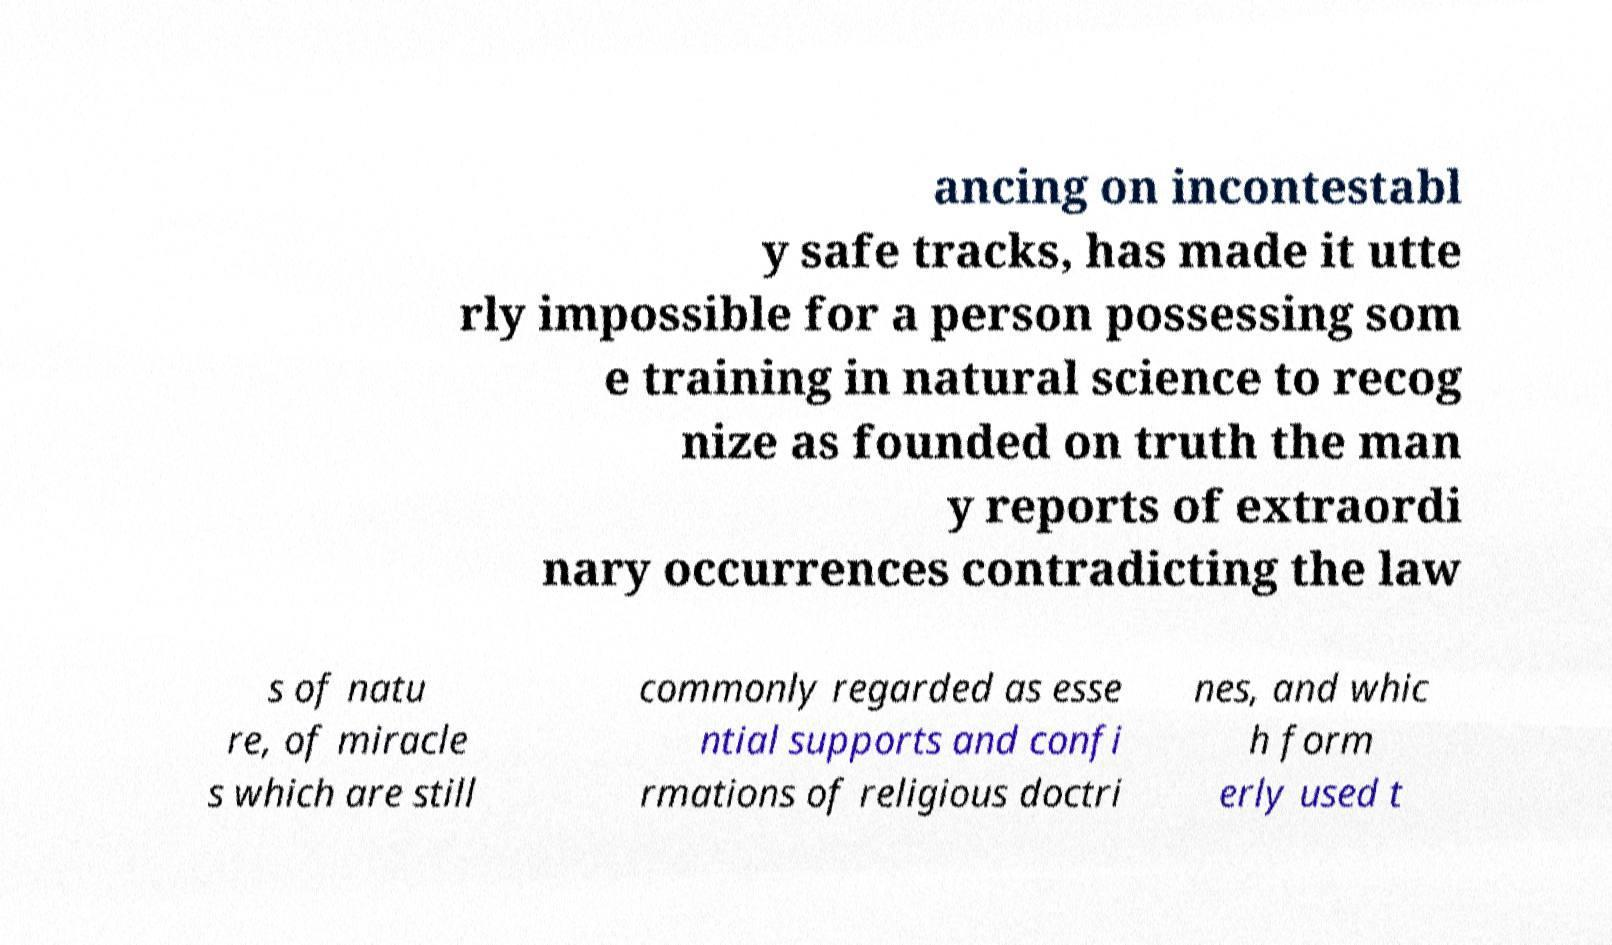Could you extract and type out the text from this image? ancing on incontestabl y safe tracks, has made it utte rly impossible for a person possessing som e training in natural science to recog nize as founded on truth the man y reports of extraordi nary occurrences contradicting the law s of natu re, of miracle s which are still commonly regarded as esse ntial supports and confi rmations of religious doctri nes, and whic h form erly used t 